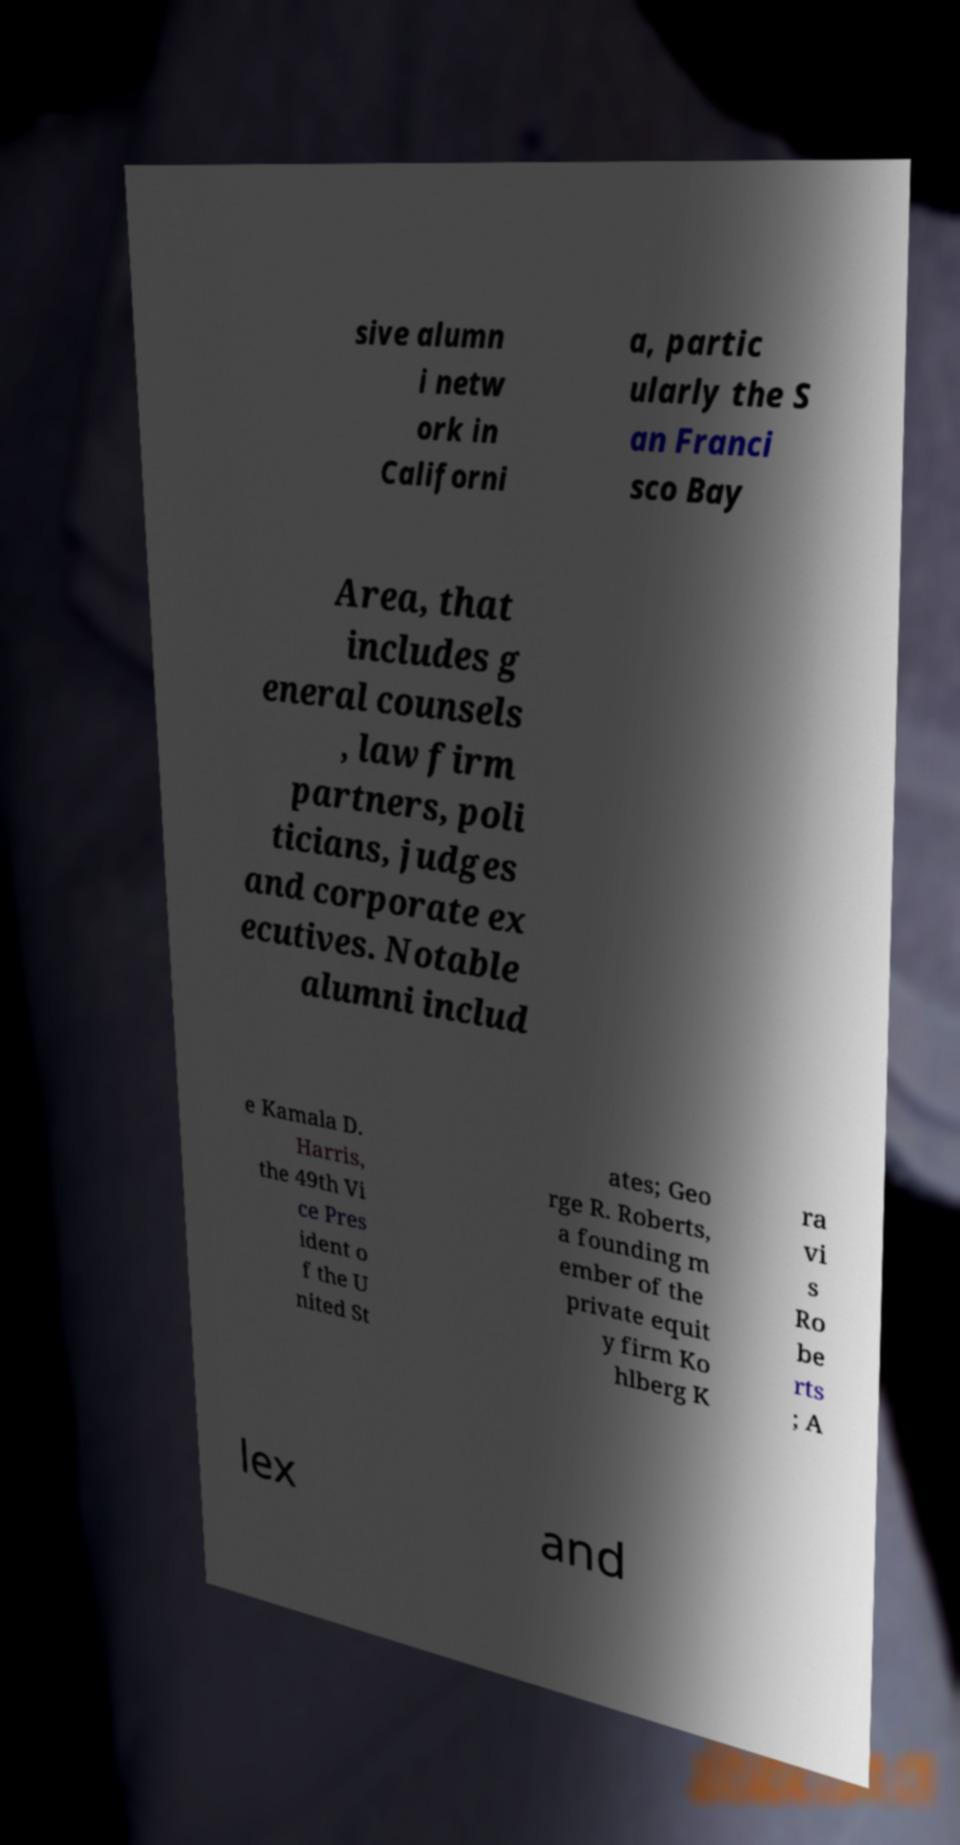There's text embedded in this image that I need extracted. Can you transcribe it verbatim? sive alumn i netw ork in Californi a, partic ularly the S an Franci sco Bay Area, that includes g eneral counsels , law firm partners, poli ticians, judges and corporate ex ecutives. Notable alumni includ e Kamala D. Harris, the 49th Vi ce Pres ident o f the U nited St ates; Geo rge R. Roberts, a founding m ember of the private equit y firm Ko hlberg K ra vi s Ro be rts ; A lex and 